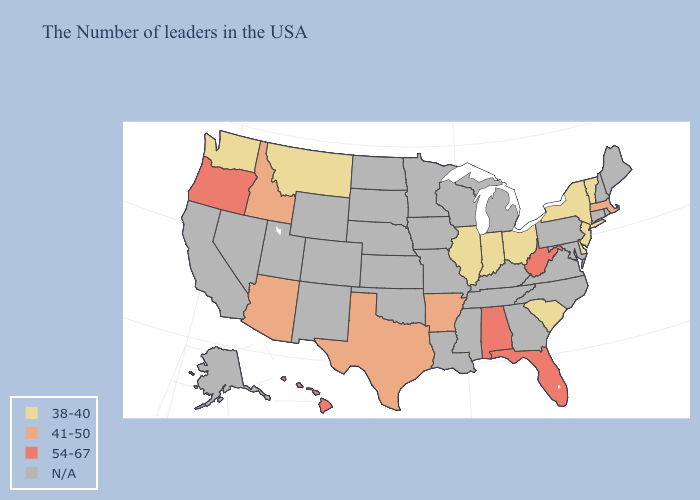Does the first symbol in the legend represent the smallest category?
Concise answer only. Yes. What is the lowest value in states that border Iowa?
Short answer required. 38-40. Name the states that have a value in the range N/A?
Short answer required. Maine, Rhode Island, New Hampshire, Connecticut, Maryland, Pennsylvania, Virginia, North Carolina, Georgia, Michigan, Kentucky, Tennessee, Wisconsin, Mississippi, Louisiana, Missouri, Minnesota, Iowa, Kansas, Nebraska, Oklahoma, South Dakota, North Dakota, Wyoming, Colorado, New Mexico, Utah, Nevada, California, Alaska. How many symbols are there in the legend?
Answer briefly. 4. Which states hav the highest value in the Northeast?
Concise answer only. Massachusetts. What is the lowest value in the MidWest?
Answer briefly. 38-40. Among the states that border Delaware , which have the lowest value?
Keep it brief. New Jersey. Among the states that border Maryland , does Delaware have the highest value?
Keep it brief. No. Does New Jersey have the highest value in the USA?
Quick response, please. No. Name the states that have a value in the range 41-50?
Keep it brief. Massachusetts, Arkansas, Texas, Arizona, Idaho. Does Oregon have the lowest value in the West?
Give a very brief answer. No. Does the map have missing data?
Quick response, please. Yes. 